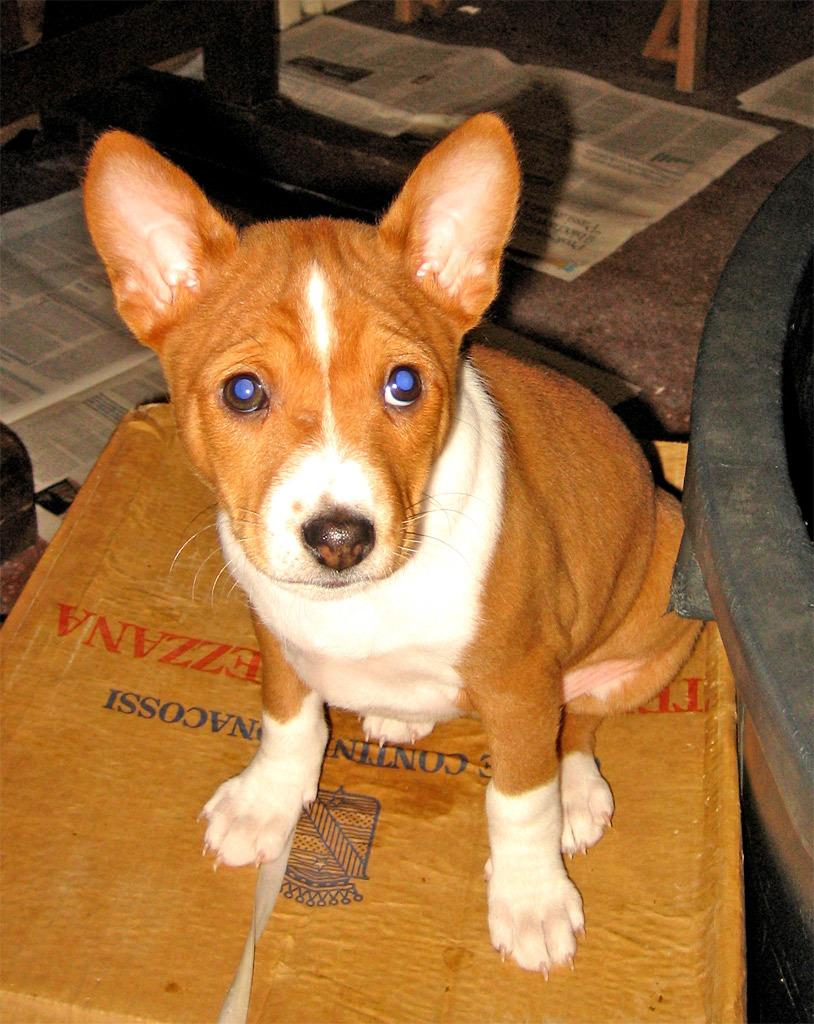What type of animal is present in the image? There is a brown color dog in the image. What is on the floor in the image? There are newspapers on the floor in the image. What type of turkey is visible in the image? There is no turkey present in the image; it features a brown color dog and newspapers on the floor. How does the dog help with the celery in the image? There is no celery present in the image, and the dog's actions are not described, so it cannot be determined how the dog might help with celery. 